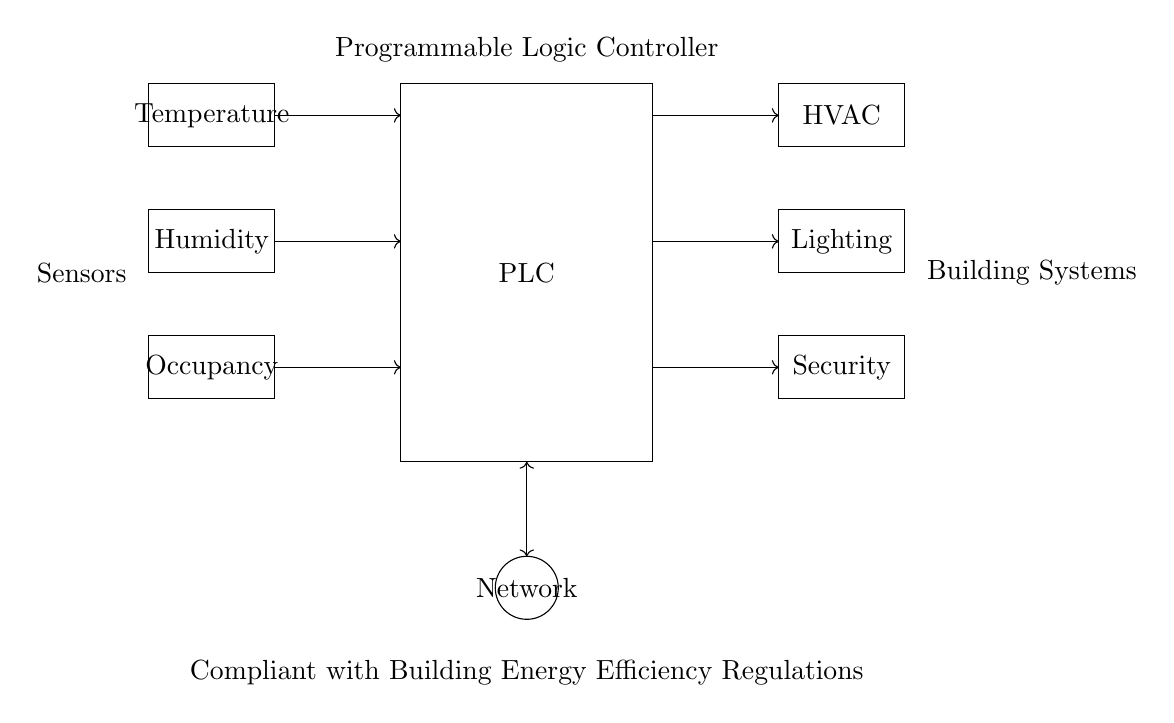What is the function of the PLC in this diagram? The PLC, or Programmable Logic Controller, serves as the central control unit that processes inputs from sensors and controls outputs to various building systems. It manages the entire automated building management system by integrating and responding to the data received from the sensors.
Answer: Programmable Logic Controller How many input modules are shown? The diagram illustrates three input modules, which include sensors for temperature, humidity, and occupancy. These modules gather data from the environment and send it to the PLC for processing.
Answer: Three What are the outputs controlled by the PLC? The PLC in this diagram controls three outputs, which are HVAC (Heating, Ventilation, and Air Conditioning), Lighting, and Security systems. These outputs enable the automated management of building environment and safety measures based on sensor data.
Answer: HVAC, Lighting, Security Which regulatory framework does this system comply with? The circuit diagram specifies that the system is "Compliant with Building Energy Efficiency Regulations". This means that it adheres to the standards and guidelines set forth for maintaining energy efficiency in buildings, likely including guidelines for automated systems.
Answer: Building Energy Efficiency Regulations How does the PLC receive data from sensors? The PLC receives data from the sensors through direct connections represented by the arrows in the diagram. These arrows indicate the flow of data from the input modules (temperature, humidity, occupancy) to the PLC, allowing it to process the information and respond accordingly.
Answer: Through direct connections 